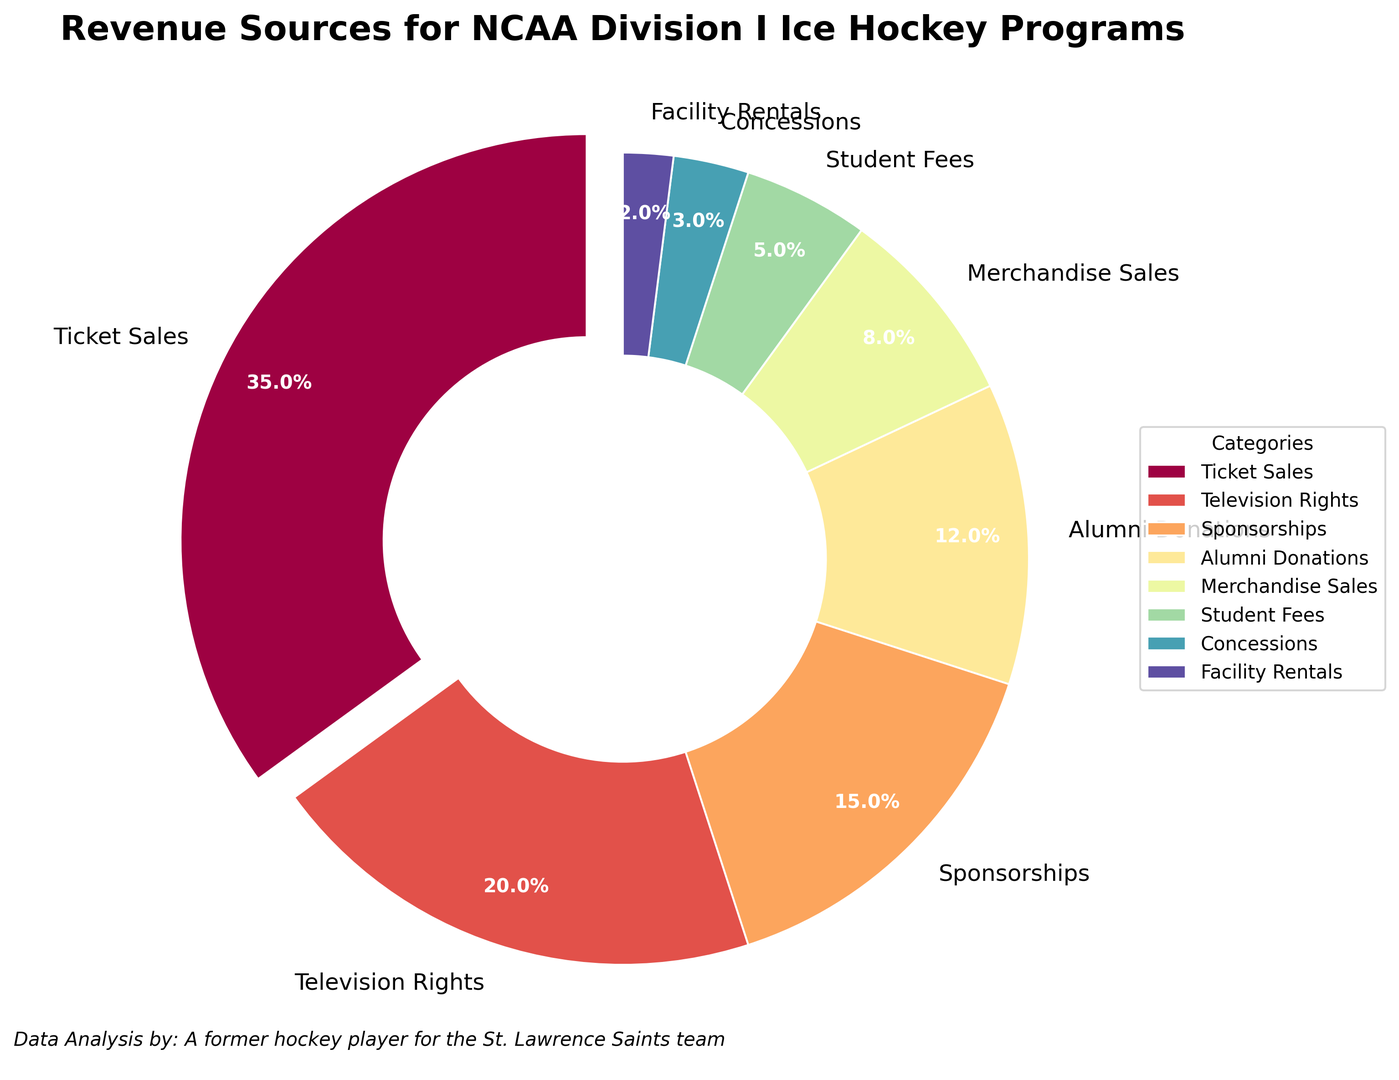Which revenue source contributes the highest percentage? The pie chart shows the contributions of various revenue sources, with the category 'Ticket Sales' being exploded, indicating its significant contribution of 35% as the largest percentage.
Answer: Ticket Sales Which two revenue sources have the closest percentage contributions? By examining the pie chart percentages, 'Student Fees' and 'Concessions' have close contributions of 5% and 3%, respectively.
Answer: Student Fees and Concessions What is the total percentage of revenue from Television Rights and Sponsorships? Add the percentages of Television Rights (20%) and Sponsorships (15%) together: 20% + 15% = 35%.
Answer: 35% Which source has a smaller percentage contribution, Merchandise Sales or Alumni Donations? Compare the percentages of Merchandise Sales (8%) and Alumni Donations (12%) from the chart. Merchandise Sales has the smaller percentage.
Answer: Merchandise Sales What could be the combined percentage contribution of Alumni Donations, Student Fees, and Concessions? Add the percentages of Alumni Donations (12%), Student Fees (5%), and Concessions (3%): 12% + 5% + 3% = 20%.
Answer: 20% Is the percentage contribution of Sponsorships greater than the combined contributions of Facility Rentals and Concessions? Sponsorships contribute 15%. The combined contribution of Facility Rentals (2%) and Concessions (3%) is 2% + 3% = 5%, which is less than Sponsorships 15%.
Answer: Yes How does the percentage contribution of Merchandise Sales compare to that of Student Fees? Merchandise Sales has a contribution of 8%, while Student Fees contribute 5%. Therefore, Merchandise Sales contributes a higher percentage.
Answer: Merchandise Sales is higher What is the percentage contribution difference between the highest and lowest revenue sources? Subtract the percentage of the lowest source (Facility Rentals at 2%) from the highest source (Ticket Sales at 35%): 35% - 2% = 33%.
Answer: 33% Assuming the percentages for the revenue sources are aggregated into three categories: Ticket Sales, Media-Related (Television Rights and Sponsorships), and Others (remaining sources), what would be their respective contributions? - Ticket Sales: 35%
- Media-Related: Television Rights (20%) + Sponsorships (15%) = 35%
- Others: Alumni Donations (12%) + Merchandise Sales (8%) + Student Fees (5%) + Concessions (3%) + Facility Rentals (2%) = 30%
Answer: Ticket Sales: 35%, Media-Related: 35%, Others: 30% 